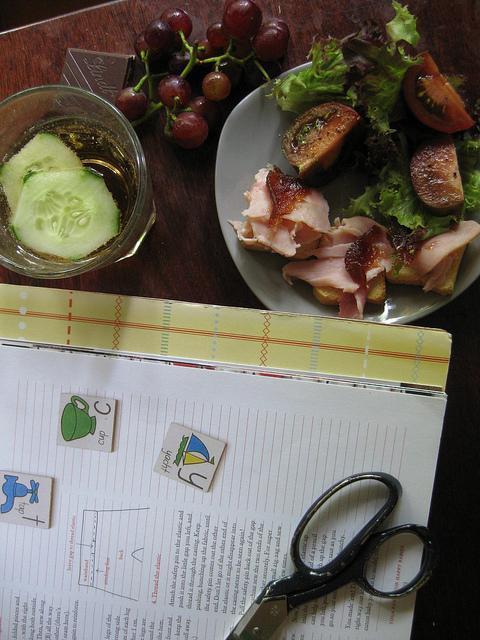How many scissors can be seen?
Give a very brief answer. 1. 